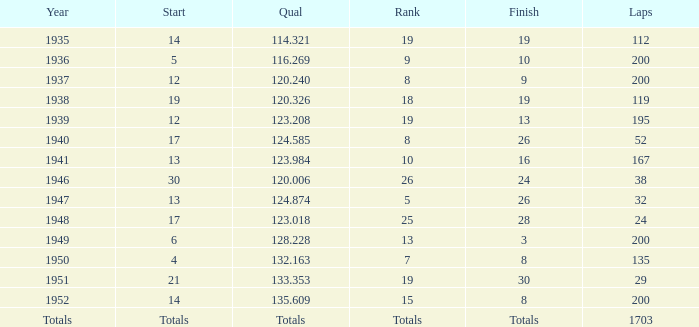In 1939, what was the end? 13.0. Parse the table in full. {'header': ['Year', 'Start', 'Qual', 'Rank', 'Finish', 'Laps'], 'rows': [['1935', '14', '114.321', '19', '19', '112'], ['1936', '5', '116.269', '9', '10', '200'], ['1937', '12', '120.240', '8', '9', '200'], ['1938', '19', '120.326', '18', '19', '119'], ['1939', '12', '123.208', '19', '13', '195'], ['1940', '17', '124.585', '8', '26', '52'], ['1941', '13', '123.984', '10', '16', '167'], ['1946', '30', '120.006', '26', '24', '38'], ['1947', '13', '124.874', '5', '26', '32'], ['1948', '17', '123.018', '25', '28', '24'], ['1949', '6', '128.228', '13', '3', '200'], ['1950', '4', '132.163', '7', '8', '135'], ['1951', '21', '133.353', '19', '30', '29'], ['1952', '14', '135.609', '15', '8', '200'], ['Totals', 'Totals', 'Totals', 'Totals', 'Totals', '1703']]} 